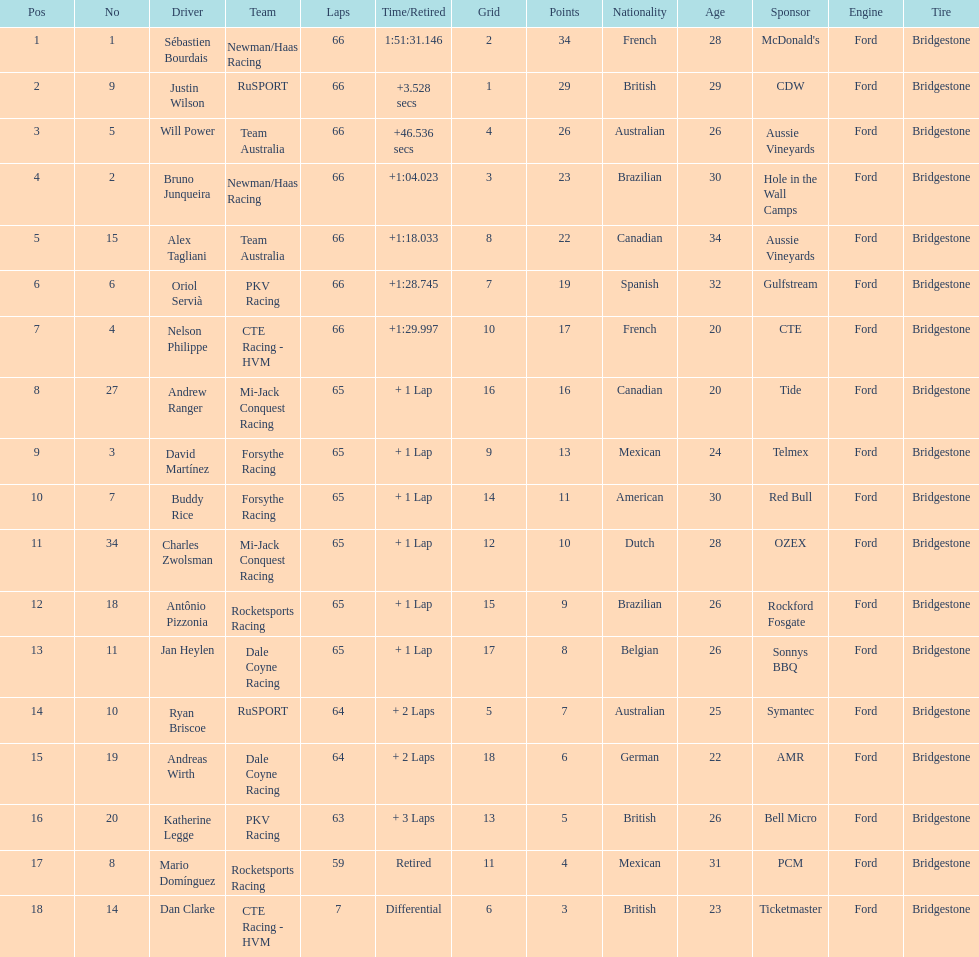Would you mind parsing the complete table? {'header': ['Pos', 'No', 'Driver', 'Team', 'Laps', 'Time/Retired', 'Grid', 'Points', 'Nationality', 'Age', 'Sponsor', 'Engine', 'Tire'], 'rows': [['1', '1', 'Sébastien Bourdais', 'Newman/Haas Racing', '66', '1:51:31.146', '2', '34', 'French', '28', "McDonald's", 'Ford', 'Bridgestone'], ['2', '9', 'Justin Wilson', 'RuSPORT', '66', '+3.528 secs', '1', '29', 'British', '29', 'CDW', 'Ford', 'Bridgestone'], ['3', '5', 'Will Power', 'Team Australia', '66', '+46.536 secs', '4', '26', 'Australian', '26', 'Aussie Vineyards', 'Ford', 'Bridgestone'], ['4', '2', 'Bruno Junqueira', 'Newman/Haas Racing', '66', '+1:04.023', '3', '23', 'Brazilian', '30', 'Hole in the Wall Camps', 'Ford', 'Bridgestone'], ['5', '15', 'Alex Tagliani', 'Team Australia', '66', '+1:18.033', '8', '22', 'Canadian', '34', 'Aussie Vineyards', 'Ford', 'Bridgestone'], ['6', '6', 'Oriol Servià', 'PKV Racing', '66', '+1:28.745', '7', '19', 'Spanish', '32', 'Gulfstream', 'Ford', 'Bridgestone'], ['7', '4', 'Nelson Philippe', 'CTE Racing - HVM', '66', '+1:29.997', '10', '17', 'French', '20', 'CTE', 'Ford', 'Bridgestone'], ['8', '27', 'Andrew Ranger', 'Mi-Jack Conquest Racing', '65', '+ 1 Lap', '16', '16', 'Canadian', '20', 'Tide', 'Ford', 'Bridgestone'], ['9', '3', 'David Martínez', 'Forsythe Racing', '65', '+ 1 Lap', '9', '13', 'Mexican', '24', 'Telmex', 'Ford', 'Bridgestone'], ['10', '7', 'Buddy Rice', 'Forsythe Racing', '65', '+ 1 Lap', '14', '11', 'American', '30', 'Red Bull', 'Ford', 'Bridgestone'], ['11', '34', 'Charles Zwolsman', 'Mi-Jack Conquest Racing', '65', '+ 1 Lap', '12', '10', 'Dutch', '28', 'OZEX', 'Ford', 'Bridgestone'], ['12', '18', 'Antônio Pizzonia', 'Rocketsports Racing', '65', '+ 1 Lap', '15', '9', 'Brazilian', '26', 'Rockford Fosgate', 'Ford', 'Bridgestone'], ['13', '11', 'Jan Heylen', 'Dale Coyne Racing', '65', '+ 1 Lap', '17', '8', 'Belgian', '26', 'Sonnys BBQ', 'Ford', 'Bridgestone'], ['14', '10', 'Ryan Briscoe', 'RuSPORT', '64', '+ 2 Laps', '5', '7', 'Australian', '25', 'Symantec', 'Ford', 'Bridgestone'], ['15', '19', 'Andreas Wirth', 'Dale Coyne Racing', '64', '+ 2 Laps', '18', '6', 'German', '22', 'AMR', 'Ford', 'Bridgestone'], ['16', '20', 'Katherine Legge', 'PKV Racing', '63', '+ 3 Laps', '13', '5', 'British', '26', 'Bell Micro', 'Ford', 'Bridgestone'], ['17', '8', 'Mario Domínguez', 'Rocketsports Racing', '59', 'Retired', '11', '4', 'Mexican', '31', 'PCM', 'Ford', 'Bridgestone'], ['18', '14', 'Dan Clarke', 'CTE Racing - HVM', '7', 'Differential', '6', '3', 'British', '23', 'Ticketmaster', 'Ford', 'Bridgestone']]} At the 2006 gran premio telmex, how many drivers completed less than 60 laps? 2. 